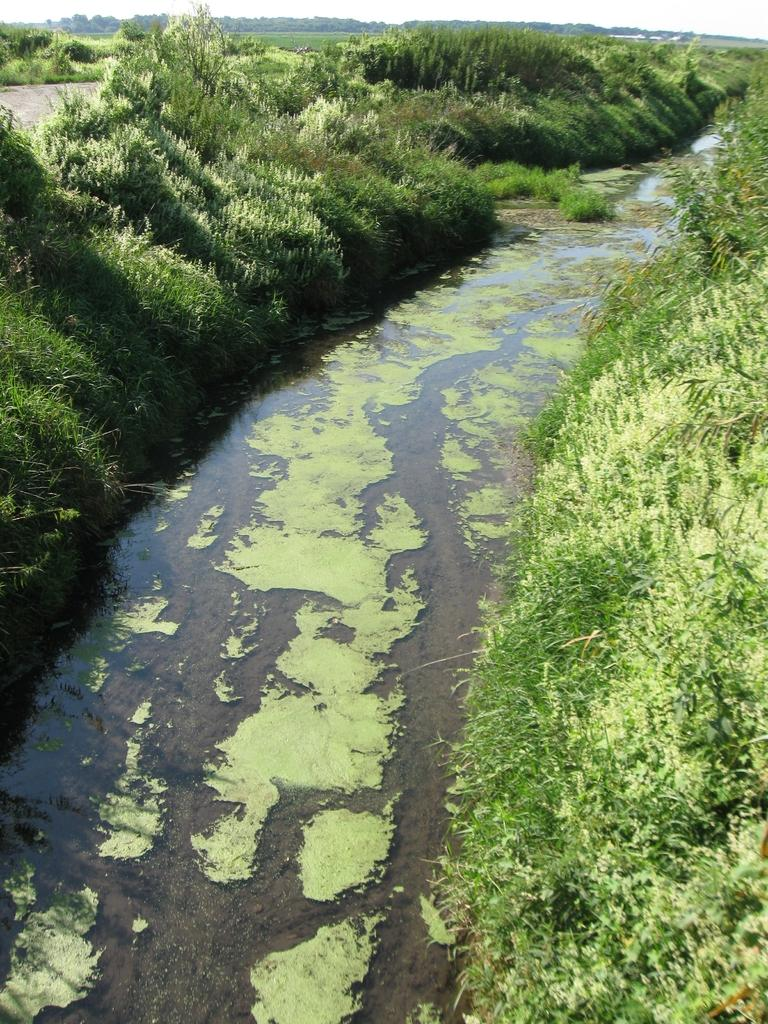What is the main subject in the center of the image? There is water in the center of the image. What type of vegetation can be seen on the right side of the image? There is greenery on the right side of the image. What type of vegetation can be seen on the left side of the image? There is greenery on the left side of the image. Can you describe the cloud formation in the image? There is no cloud formation present in the image; it only features water and greenery. Are there any people swimming in the water in the image? There is no indication of people swimming in the water in the image. 